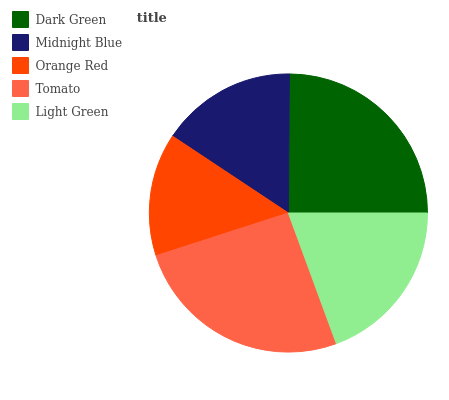Is Orange Red the minimum?
Answer yes or no. Yes. Is Tomato the maximum?
Answer yes or no. Yes. Is Midnight Blue the minimum?
Answer yes or no. No. Is Midnight Blue the maximum?
Answer yes or no. No. Is Dark Green greater than Midnight Blue?
Answer yes or no. Yes. Is Midnight Blue less than Dark Green?
Answer yes or no. Yes. Is Midnight Blue greater than Dark Green?
Answer yes or no. No. Is Dark Green less than Midnight Blue?
Answer yes or no. No. Is Light Green the high median?
Answer yes or no. Yes. Is Light Green the low median?
Answer yes or no. Yes. Is Tomato the high median?
Answer yes or no. No. Is Dark Green the low median?
Answer yes or no. No. 